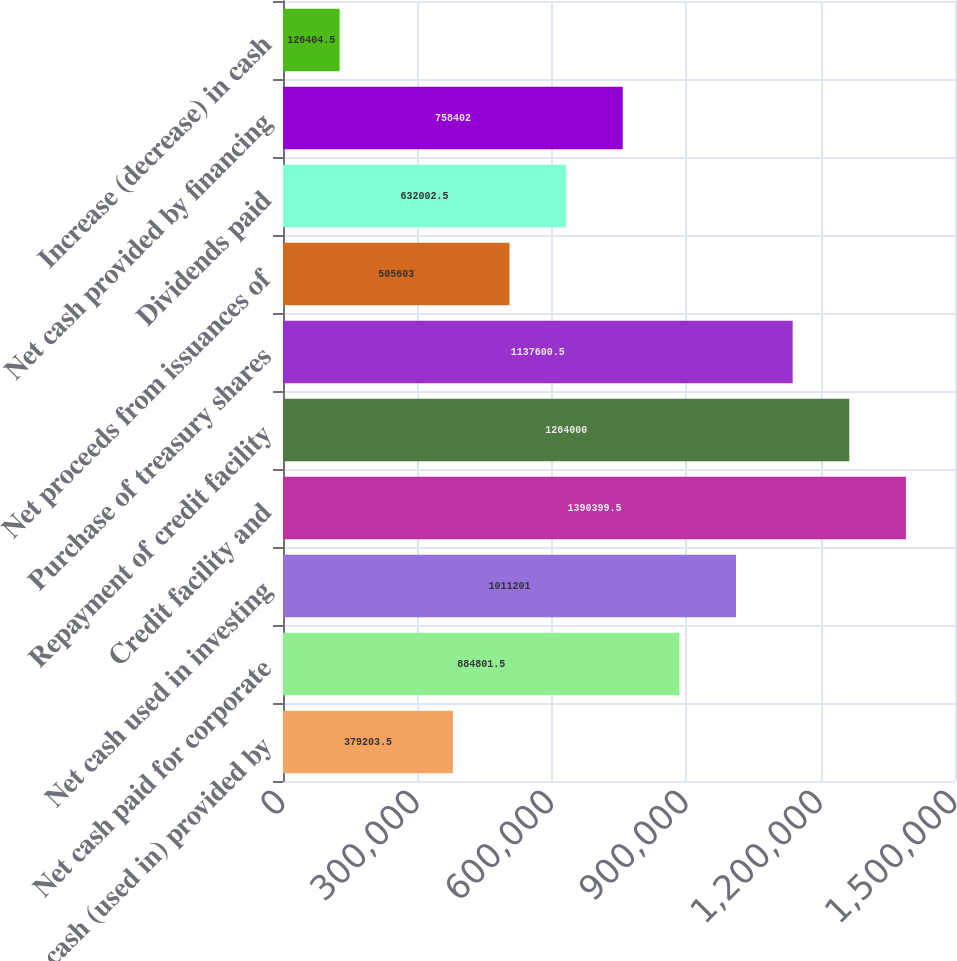<chart> <loc_0><loc_0><loc_500><loc_500><bar_chart><fcel>Net cash (used in) provided by<fcel>Net cash paid for corporate<fcel>Net cash used in investing<fcel>Credit facility and<fcel>Repayment of credit facility<fcel>Purchase of treasury shares<fcel>Net proceeds from issuances of<fcel>Dividends paid<fcel>Net cash provided by financing<fcel>Increase (decrease) in cash<nl><fcel>379204<fcel>884802<fcel>1.0112e+06<fcel>1.3904e+06<fcel>1.264e+06<fcel>1.1376e+06<fcel>505603<fcel>632002<fcel>758402<fcel>126404<nl></chart> 